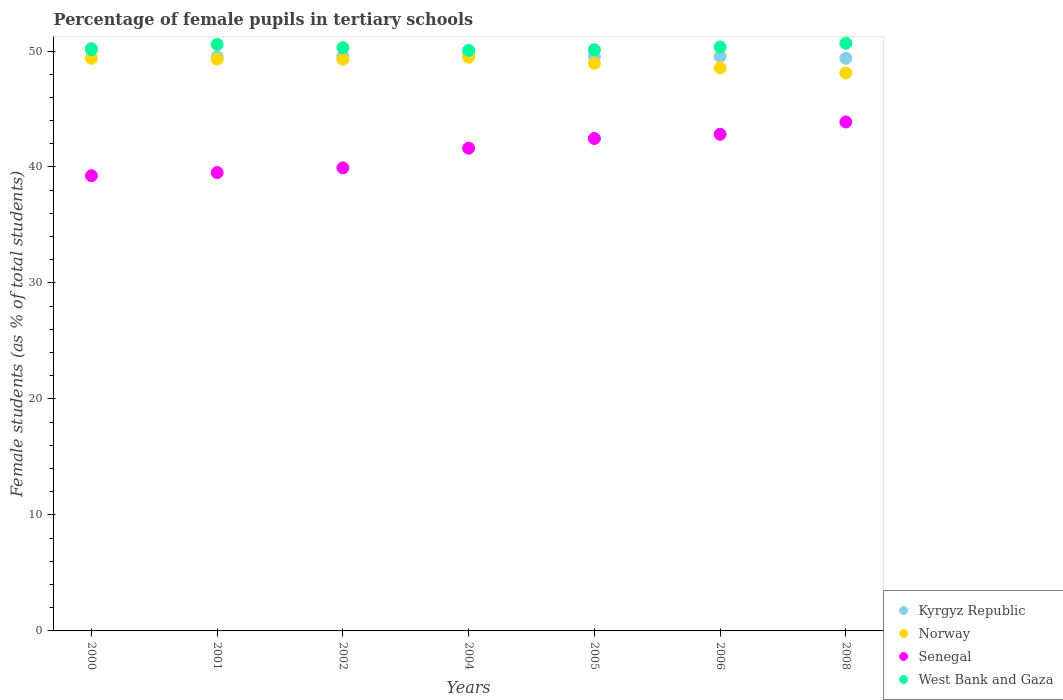How many different coloured dotlines are there?
Your response must be concise. 4. What is the percentage of female pupils in tertiary schools in Kyrgyz Republic in 2008?
Make the answer very short. 49.37. Across all years, what is the maximum percentage of female pupils in tertiary schools in Kyrgyz Republic?
Provide a succinct answer. 50.24. Across all years, what is the minimum percentage of female pupils in tertiary schools in Kyrgyz Republic?
Offer a terse response. 49.37. In which year was the percentage of female pupils in tertiary schools in West Bank and Gaza maximum?
Make the answer very short. 2008. In which year was the percentage of female pupils in tertiary schools in Norway minimum?
Offer a very short reply. 2008. What is the total percentage of female pupils in tertiary schools in Norway in the graph?
Your response must be concise. 342.99. What is the difference between the percentage of female pupils in tertiary schools in Kyrgyz Republic in 2001 and that in 2004?
Your answer should be compact. -0.11. What is the difference between the percentage of female pupils in tertiary schools in Norway in 2006 and the percentage of female pupils in tertiary schools in Kyrgyz Republic in 2008?
Provide a short and direct response. -0.84. What is the average percentage of female pupils in tertiary schools in West Bank and Gaza per year?
Offer a very short reply. 50.31. In the year 2008, what is the difference between the percentage of female pupils in tertiary schools in Norway and percentage of female pupils in tertiary schools in West Bank and Gaza?
Offer a terse response. -2.57. What is the ratio of the percentage of female pupils in tertiary schools in Norway in 2000 to that in 2005?
Your response must be concise. 1.01. Is the percentage of female pupils in tertiary schools in West Bank and Gaza in 2000 less than that in 2005?
Offer a very short reply. No. What is the difference between the highest and the second highest percentage of female pupils in tertiary schools in West Bank and Gaza?
Offer a very short reply. 0.1. What is the difference between the highest and the lowest percentage of female pupils in tertiary schools in West Bank and Gaza?
Your answer should be compact. 0.62. Is the percentage of female pupils in tertiary schools in Senegal strictly greater than the percentage of female pupils in tertiary schools in Kyrgyz Republic over the years?
Keep it short and to the point. No. Is the percentage of female pupils in tertiary schools in West Bank and Gaza strictly less than the percentage of female pupils in tertiary schools in Kyrgyz Republic over the years?
Your response must be concise. No. How many dotlines are there?
Provide a succinct answer. 4. Does the graph contain grids?
Offer a terse response. No. Where does the legend appear in the graph?
Make the answer very short. Bottom right. How many legend labels are there?
Offer a terse response. 4. What is the title of the graph?
Provide a short and direct response. Percentage of female pupils in tertiary schools. What is the label or title of the X-axis?
Provide a short and direct response. Years. What is the label or title of the Y-axis?
Make the answer very short. Female students (as % of total students). What is the Female students (as % of total students) of Kyrgyz Republic in 2000?
Give a very brief answer. 50.24. What is the Female students (as % of total students) of Norway in 2000?
Your answer should be very brief. 49.37. What is the Female students (as % of total students) in Senegal in 2000?
Offer a terse response. 39.25. What is the Female students (as % of total students) in West Bank and Gaza in 2000?
Provide a short and direct response. 50.12. What is the Female students (as % of total students) of Kyrgyz Republic in 2001?
Provide a short and direct response. 49.5. What is the Female students (as % of total students) in Norway in 2001?
Ensure brevity in your answer.  49.3. What is the Female students (as % of total students) of Senegal in 2001?
Make the answer very short. 39.52. What is the Female students (as % of total students) in West Bank and Gaza in 2001?
Your answer should be very brief. 50.57. What is the Female students (as % of total students) of Kyrgyz Republic in 2002?
Keep it short and to the point. 49.55. What is the Female students (as % of total students) of Norway in 2002?
Your answer should be very brief. 49.29. What is the Female students (as % of total students) in Senegal in 2002?
Your answer should be compact. 39.92. What is the Female students (as % of total students) in West Bank and Gaza in 2002?
Make the answer very short. 50.29. What is the Female students (as % of total students) in Kyrgyz Republic in 2004?
Provide a succinct answer. 49.61. What is the Female students (as % of total students) in Norway in 2004?
Give a very brief answer. 49.46. What is the Female students (as % of total students) of Senegal in 2004?
Your response must be concise. 41.62. What is the Female students (as % of total students) of West Bank and Gaza in 2004?
Your answer should be compact. 50.05. What is the Female students (as % of total students) in Kyrgyz Republic in 2005?
Give a very brief answer. 49.5. What is the Female students (as % of total students) of Norway in 2005?
Your answer should be compact. 48.94. What is the Female students (as % of total students) of Senegal in 2005?
Offer a terse response. 42.46. What is the Female students (as % of total students) in West Bank and Gaza in 2005?
Offer a terse response. 50.11. What is the Female students (as % of total students) in Kyrgyz Republic in 2006?
Your response must be concise. 49.53. What is the Female students (as % of total students) of Norway in 2006?
Offer a very short reply. 48.54. What is the Female students (as % of total students) in Senegal in 2006?
Your answer should be very brief. 42.82. What is the Female students (as % of total students) of West Bank and Gaza in 2006?
Provide a short and direct response. 50.35. What is the Female students (as % of total students) in Kyrgyz Republic in 2008?
Your response must be concise. 49.37. What is the Female students (as % of total students) of Norway in 2008?
Your answer should be compact. 48.1. What is the Female students (as % of total students) of Senegal in 2008?
Ensure brevity in your answer.  43.88. What is the Female students (as % of total students) of West Bank and Gaza in 2008?
Give a very brief answer. 50.67. Across all years, what is the maximum Female students (as % of total students) of Kyrgyz Republic?
Your response must be concise. 50.24. Across all years, what is the maximum Female students (as % of total students) of Norway?
Keep it short and to the point. 49.46. Across all years, what is the maximum Female students (as % of total students) of Senegal?
Make the answer very short. 43.88. Across all years, what is the maximum Female students (as % of total students) in West Bank and Gaza?
Your answer should be very brief. 50.67. Across all years, what is the minimum Female students (as % of total students) in Kyrgyz Republic?
Give a very brief answer. 49.37. Across all years, what is the minimum Female students (as % of total students) in Norway?
Offer a terse response. 48.1. Across all years, what is the minimum Female students (as % of total students) of Senegal?
Keep it short and to the point. 39.25. Across all years, what is the minimum Female students (as % of total students) of West Bank and Gaza?
Keep it short and to the point. 50.05. What is the total Female students (as % of total students) in Kyrgyz Republic in the graph?
Your response must be concise. 347.3. What is the total Female students (as % of total students) in Norway in the graph?
Your answer should be very brief. 342.99. What is the total Female students (as % of total students) of Senegal in the graph?
Give a very brief answer. 289.47. What is the total Female students (as % of total students) of West Bank and Gaza in the graph?
Provide a succinct answer. 352.15. What is the difference between the Female students (as % of total students) of Kyrgyz Republic in 2000 and that in 2001?
Offer a very short reply. 0.74. What is the difference between the Female students (as % of total students) of Norway in 2000 and that in 2001?
Give a very brief answer. 0.08. What is the difference between the Female students (as % of total students) in Senegal in 2000 and that in 2001?
Your answer should be compact. -0.27. What is the difference between the Female students (as % of total students) of West Bank and Gaza in 2000 and that in 2001?
Make the answer very short. -0.46. What is the difference between the Female students (as % of total students) of Kyrgyz Republic in 2000 and that in 2002?
Your answer should be compact. 0.69. What is the difference between the Female students (as % of total students) in Norway in 2000 and that in 2002?
Offer a terse response. 0.08. What is the difference between the Female students (as % of total students) in Senegal in 2000 and that in 2002?
Keep it short and to the point. -0.68. What is the difference between the Female students (as % of total students) in West Bank and Gaza in 2000 and that in 2002?
Offer a terse response. -0.17. What is the difference between the Female students (as % of total students) of Kyrgyz Republic in 2000 and that in 2004?
Provide a short and direct response. 0.63. What is the difference between the Female students (as % of total students) of Norway in 2000 and that in 2004?
Your answer should be compact. -0.09. What is the difference between the Female students (as % of total students) of Senegal in 2000 and that in 2004?
Your response must be concise. -2.38. What is the difference between the Female students (as % of total students) in West Bank and Gaza in 2000 and that in 2004?
Offer a terse response. 0.07. What is the difference between the Female students (as % of total students) of Kyrgyz Republic in 2000 and that in 2005?
Ensure brevity in your answer.  0.74. What is the difference between the Female students (as % of total students) of Norway in 2000 and that in 2005?
Provide a succinct answer. 0.43. What is the difference between the Female students (as % of total students) in Senegal in 2000 and that in 2005?
Your response must be concise. -3.21. What is the difference between the Female students (as % of total students) of West Bank and Gaza in 2000 and that in 2005?
Provide a succinct answer. 0.01. What is the difference between the Female students (as % of total students) in Norway in 2000 and that in 2006?
Your answer should be compact. 0.84. What is the difference between the Female students (as % of total students) of Senegal in 2000 and that in 2006?
Your answer should be very brief. -3.57. What is the difference between the Female students (as % of total students) of West Bank and Gaza in 2000 and that in 2006?
Your answer should be very brief. -0.23. What is the difference between the Female students (as % of total students) in Kyrgyz Republic in 2000 and that in 2008?
Give a very brief answer. 0.87. What is the difference between the Female students (as % of total students) in Norway in 2000 and that in 2008?
Your answer should be compact. 1.27. What is the difference between the Female students (as % of total students) in Senegal in 2000 and that in 2008?
Your answer should be very brief. -4.64. What is the difference between the Female students (as % of total students) in West Bank and Gaza in 2000 and that in 2008?
Give a very brief answer. -0.56. What is the difference between the Female students (as % of total students) in Kyrgyz Republic in 2001 and that in 2002?
Provide a short and direct response. -0.05. What is the difference between the Female students (as % of total students) of Norway in 2001 and that in 2002?
Your response must be concise. 0.01. What is the difference between the Female students (as % of total students) in Senegal in 2001 and that in 2002?
Your answer should be very brief. -0.41. What is the difference between the Female students (as % of total students) in West Bank and Gaza in 2001 and that in 2002?
Your answer should be compact. 0.29. What is the difference between the Female students (as % of total students) in Kyrgyz Republic in 2001 and that in 2004?
Your answer should be compact. -0.11. What is the difference between the Female students (as % of total students) in Norway in 2001 and that in 2004?
Offer a terse response. -0.17. What is the difference between the Female students (as % of total students) in Senegal in 2001 and that in 2004?
Ensure brevity in your answer.  -2.1. What is the difference between the Female students (as % of total students) of West Bank and Gaza in 2001 and that in 2004?
Your answer should be compact. 0.52. What is the difference between the Female students (as % of total students) of Kyrgyz Republic in 2001 and that in 2005?
Keep it short and to the point. 0. What is the difference between the Female students (as % of total students) of Norway in 2001 and that in 2005?
Offer a terse response. 0.36. What is the difference between the Female students (as % of total students) of Senegal in 2001 and that in 2005?
Keep it short and to the point. -2.94. What is the difference between the Female students (as % of total students) in West Bank and Gaza in 2001 and that in 2005?
Offer a very short reply. 0.46. What is the difference between the Female students (as % of total students) of Kyrgyz Republic in 2001 and that in 2006?
Offer a terse response. -0.02. What is the difference between the Female students (as % of total students) in Norway in 2001 and that in 2006?
Make the answer very short. 0.76. What is the difference between the Female students (as % of total students) of Senegal in 2001 and that in 2006?
Provide a short and direct response. -3.3. What is the difference between the Female students (as % of total students) in West Bank and Gaza in 2001 and that in 2006?
Your answer should be very brief. 0.22. What is the difference between the Female students (as % of total students) in Kyrgyz Republic in 2001 and that in 2008?
Offer a terse response. 0.13. What is the difference between the Female students (as % of total students) in Norway in 2001 and that in 2008?
Keep it short and to the point. 1.2. What is the difference between the Female students (as % of total students) of Senegal in 2001 and that in 2008?
Keep it short and to the point. -4.36. What is the difference between the Female students (as % of total students) of West Bank and Gaza in 2001 and that in 2008?
Ensure brevity in your answer.  -0.1. What is the difference between the Female students (as % of total students) in Kyrgyz Republic in 2002 and that in 2004?
Offer a very short reply. -0.06. What is the difference between the Female students (as % of total students) in Norway in 2002 and that in 2004?
Offer a terse response. -0.17. What is the difference between the Female students (as % of total students) of Senegal in 2002 and that in 2004?
Offer a very short reply. -1.7. What is the difference between the Female students (as % of total students) of West Bank and Gaza in 2002 and that in 2004?
Your answer should be compact. 0.24. What is the difference between the Female students (as % of total students) of Kyrgyz Republic in 2002 and that in 2005?
Provide a short and direct response. 0.06. What is the difference between the Female students (as % of total students) in Norway in 2002 and that in 2005?
Your response must be concise. 0.35. What is the difference between the Female students (as % of total students) in Senegal in 2002 and that in 2005?
Make the answer very short. -2.53. What is the difference between the Female students (as % of total students) of West Bank and Gaza in 2002 and that in 2005?
Offer a very short reply. 0.18. What is the difference between the Female students (as % of total students) in Kyrgyz Republic in 2002 and that in 2006?
Your answer should be very brief. 0.03. What is the difference between the Female students (as % of total students) in Norway in 2002 and that in 2006?
Offer a very short reply. 0.75. What is the difference between the Female students (as % of total students) of Senegal in 2002 and that in 2006?
Provide a short and direct response. -2.89. What is the difference between the Female students (as % of total students) of West Bank and Gaza in 2002 and that in 2006?
Offer a very short reply. -0.06. What is the difference between the Female students (as % of total students) in Kyrgyz Republic in 2002 and that in 2008?
Keep it short and to the point. 0.18. What is the difference between the Female students (as % of total students) of Norway in 2002 and that in 2008?
Offer a very short reply. 1.19. What is the difference between the Female students (as % of total students) of Senegal in 2002 and that in 2008?
Your response must be concise. -3.96. What is the difference between the Female students (as % of total students) of West Bank and Gaza in 2002 and that in 2008?
Your response must be concise. -0.39. What is the difference between the Female students (as % of total students) of Kyrgyz Republic in 2004 and that in 2005?
Keep it short and to the point. 0.11. What is the difference between the Female students (as % of total students) in Norway in 2004 and that in 2005?
Provide a succinct answer. 0.52. What is the difference between the Female students (as % of total students) in Senegal in 2004 and that in 2005?
Offer a terse response. -0.84. What is the difference between the Female students (as % of total students) in West Bank and Gaza in 2004 and that in 2005?
Your response must be concise. -0.06. What is the difference between the Female students (as % of total students) in Kyrgyz Republic in 2004 and that in 2006?
Your answer should be compact. 0.08. What is the difference between the Female students (as % of total students) of Norway in 2004 and that in 2006?
Give a very brief answer. 0.93. What is the difference between the Female students (as % of total students) of Senegal in 2004 and that in 2006?
Offer a terse response. -1.2. What is the difference between the Female students (as % of total students) in West Bank and Gaza in 2004 and that in 2006?
Provide a short and direct response. -0.3. What is the difference between the Female students (as % of total students) of Kyrgyz Republic in 2004 and that in 2008?
Offer a terse response. 0.24. What is the difference between the Female students (as % of total students) in Norway in 2004 and that in 2008?
Your response must be concise. 1.36. What is the difference between the Female students (as % of total students) in Senegal in 2004 and that in 2008?
Give a very brief answer. -2.26. What is the difference between the Female students (as % of total students) of West Bank and Gaza in 2004 and that in 2008?
Provide a succinct answer. -0.62. What is the difference between the Female students (as % of total students) in Kyrgyz Republic in 2005 and that in 2006?
Your answer should be compact. -0.03. What is the difference between the Female students (as % of total students) of Norway in 2005 and that in 2006?
Your answer should be very brief. 0.4. What is the difference between the Female students (as % of total students) of Senegal in 2005 and that in 2006?
Offer a very short reply. -0.36. What is the difference between the Female students (as % of total students) in West Bank and Gaza in 2005 and that in 2006?
Your answer should be very brief. -0.24. What is the difference between the Female students (as % of total students) of Kyrgyz Republic in 2005 and that in 2008?
Provide a succinct answer. 0.13. What is the difference between the Female students (as % of total students) of Norway in 2005 and that in 2008?
Provide a short and direct response. 0.84. What is the difference between the Female students (as % of total students) of Senegal in 2005 and that in 2008?
Provide a succinct answer. -1.43. What is the difference between the Female students (as % of total students) in West Bank and Gaza in 2005 and that in 2008?
Your answer should be compact. -0.57. What is the difference between the Female students (as % of total students) in Kyrgyz Republic in 2006 and that in 2008?
Offer a very short reply. 0.15. What is the difference between the Female students (as % of total students) in Norway in 2006 and that in 2008?
Give a very brief answer. 0.43. What is the difference between the Female students (as % of total students) in Senegal in 2006 and that in 2008?
Give a very brief answer. -1.06. What is the difference between the Female students (as % of total students) of West Bank and Gaza in 2006 and that in 2008?
Ensure brevity in your answer.  -0.32. What is the difference between the Female students (as % of total students) in Kyrgyz Republic in 2000 and the Female students (as % of total students) in Norway in 2001?
Your answer should be compact. 0.94. What is the difference between the Female students (as % of total students) of Kyrgyz Republic in 2000 and the Female students (as % of total students) of Senegal in 2001?
Your answer should be very brief. 10.72. What is the difference between the Female students (as % of total students) of Kyrgyz Republic in 2000 and the Female students (as % of total students) of West Bank and Gaza in 2001?
Ensure brevity in your answer.  -0.33. What is the difference between the Female students (as % of total students) in Norway in 2000 and the Female students (as % of total students) in Senegal in 2001?
Offer a terse response. 9.85. What is the difference between the Female students (as % of total students) in Norway in 2000 and the Female students (as % of total students) in West Bank and Gaza in 2001?
Provide a succinct answer. -1.2. What is the difference between the Female students (as % of total students) in Senegal in 2000 and the Female students (as % of total students) in West Bank and Gaza in 2001?
Provide a succinct answer. -11.33. What is the difference between the Female students (as % of total students) in Kyrgyz Republic in 2000 and the Female students (as % of total students) in Norway in 2002?
Provide a short and direct response. 0.95. What is the difference between the Female students (as % of total students) of Kyrgyz Republic in 2000 and the Female students (as % of total students) of Senegal in 2002?
Offer a very short reply. 10.32. What is the difference between the Female students (as % of total students) of Kyrgyz Republic in 2000 and the Female students (as % of total students) of West Bank and Gaza in 2002?
Offer a very short reply. -0.05. What is the difference between the Female students (as % of total students) of Norway in 2000 and the Female students (as % of total students) of Senegal in 2002?
Offer a very short reply. 9.45. What is the difference between the Female students (as % of total students) in Norway in 2000 and the Female students (as % of total students) in West Bank and Gaza in 2002?
Keep it short and to the point. -0.92. What is the difference between the Female students (as % of total students) in Senegal in 2000 and the Female students (as % of total students) in West Bank and Gaza in 2002?
Your response must be concise. -11.04. What is the difference between the Female students (as % of total students) in Kyrgyz Republic in 2000 and the Female students (as % of total students) in Norway in 2004?
Provide a short and direct response. 0.78. What is the difference between the Female students (as % of total students) of Kyrgyz Republic in 2000 and the Female students (as % of total students) of Senegal in 2004?
Your answer should be compact. 8.62. What is the difference between the Female students (as % of total students) in Kyrgyz Republic in 2000 and the Female students (as % of total students) in West Bank and Gaza in 2004?
Provide a short and direct response. 0.19. What is the difference between the Female students (as % of total students) in Norway in 2000 and the Female students (as % of total students) in Senegal in 2004?
Keep it short and to the point. 7.75. What is the difference between the Female students (as % of total students) in Norway in 2000 and the Female students (as % of total students) in West Bank and Gaza in 2004?
Ensure brevity in your answer.  -0.68. What is the difference between the Female students (as % of total students) of Senegal in 2000 and the Female students (as % of total students) of West Bank and Gaza in 2004?
Ensure brevity in your answer.  -10.81. What is the difference between the Female students (as % of total students) of Kyrgyz Republic in 2000 and the Female students (as % of total students) of Norway in 2005?
Keep it short and to the point. 1.3. What is the difference between the Female students (as % of total students) in Kyrgyz Republic in 2000 and the Female students (as % of total students) in Senegal in 2005?
Provide a succinct answer. 7.78. What is the difference between the Female students (as % of total students) in Kyrgyz Republic in 2000 and the Female students (as % of total students) in West Bank and Gaza in 2005?
Provide a succinct answer. 0.13. What is the difference between the Female students (as % of total students) of Norway in 2000 and the Female students (as % of total students) of Senegal in 2005?
Ensure brevity in your answer.  6.91. What is the difference between the Female students (as % of total students) of Norway in 2000 and the Female students (as % of total students) of West Bank and Gaza in 2005?
Make the answer very short. -0.74. What is the difference between the Female students (as % of total students) in Senegal in 2000 and the Female students (as % of total students) in West Bank and Gaza in 2005?
Offer a terse response. -10.86. What is the difference between the Female students (as % of total students) in Kyrgyz Republic in 2000 and the Female students (as % of total students) in Norway in 2006?
Offer a terse response. 1.7. What is the difference between the Female students (as % of total students) in Kyrgyz Republic in 2000 and the Female students (as % of total students) in Senegal in 2006?
Give a very brief answer. 7.42. What is the difference between the Female students (as % of total students) in Kyrgyz Republic in 2000 and the Female students (as % of total students) in West Bank and Gaza in 2006?
Your answer should be compact. -0.11. What is the difference between the Female students (as % of total students) in Norway in 2000 and the Female students (as % of total students) in Senegal in 2006?
Provide a succinct answer. 6.55. What is the difference between the Female students (as % of total students) in Norway in 2000 and the Female students (as % of total students) in West Bank and Gaza in 2006?
Give a very brief answer. -0.98. What is the difference between the Female students (as % of total students) in Senegal in 2000 and the Female students (as % of total students) in West Bank and Gaza in 2006?
Your response must be concise. -11.1. What is the difference between the Female students (as % of total students) in Kyrgyz Republic in 2000 and the Female students (as % of total students) in Norway in 2008?
Offer a very short reply. 2.14. What is the difference between the Female students (as % of total students) in Kyrgyz Republic in 2000 and the Female students (as % of total students) in Senegal in 2008?
Provide a short and direct response. 6.36. What is the difference between the Female students (as % of total students) in Kyrgyz Republic in 2000 and the Female students (as % of total students) in West Bank and Gaza in 2008?
Give a very brief answer. -0.43. What is the difference between the Female students (as % of total students) in Norway in 2000 and the Female students (as % of total students) in Senegal in 2008?
Your response must be concise. 5.49. What is the difference between the Female students (as % of total students) of Norway in 2000 and the Female students (as % of total students) of West Bank and Gaza in 2008?
Provide a short and direct response. -1.3. What is the difference between the Female students (as % of total students) of Senegal in 2000 and the Female students (as % of total students) of West Bank and Gaza in 2008?
Provide a succinct answer. -11.43. What is the difference between the Female students (as % of total students) in Kyrgyz Republic in 2001 and the Female students (as % of total students) in Norway in 2002?
Offer a terse response. 0.21. What is the difference between the Female students (as % of total students) of Kyrgyz Republic in 2001 and the Female students (as % of total students) of Senegal in 2002?
Provide a short and direct response. 9.58. What is the difference between the Female students (as % of total students) in Kyrgyz Republic in 2001 and the Female students (as % of total students) in West Bank and Gaza in 2002?
Offer a very short reply. -0.79. What is the difference between the Female students (as % of total students) of Norway in 2001 and the Female students (as % of total students) of Senegal in 2002?
Offer a terse response. 9.37. What is the difference between the Female students (as % of total students) in Norway in 2001 and the Female students (as % of total students) in West Bank and Gaza in 2002?
Your answer should be very brief. -0.99. What is the difference between the Female students (as % of total students) in Senegal in 2001 and the Female students (as % of total students) in West Bank and Gaza in 2002?
Offer a very short reply. -10.77. What is the difference between the Female students (as % of total students) of Kyrgyz Republic in 2001 and the Female students (as % of total students) of Norway in 2004?
Your response must be concise. 0.04. What is the difference between the Female students (as % of total students) of Kyrgyz Republic in 2001 and the Female students (as % of total students) of Senegal in 2004?
Your response must be concise. 7.88. What is the difference between the Female students (as % of total students) in Kyrgyz Republic in 2001 and the Female students (as % of total students) in West Bank and Gaza in 2004?
Make the answer very short. -0.55. What is the difference between the Female students (as % of total students) in Norway in 2001 and the Female students (as % of total students) in Senegal in 2004?
Ensure brevity in your answer.  7.67. What is the difference between the Female students (as % of total students) of Norway in 2001 and the Female students (as % of total students) of West Bank and Gaza in 2004?
Offer a very short reply. -0.76. What is the difference between the Female students (as % of total students) in Senegal in 2001 and the Female students (as % of total students) in West Bank and Gaza in 2004?
Offer a very short reply. -10.53. What is the difference between the Female students (as % of total students) of Kyrgyz Republic in 2001 and the Female students (as % of total students) of Norway in 2005?
Make the answer very short. 0.56. What is the difference between the Female students (as % of total students) of Kyrgyz Republic in 2001 and the Female students (as % of total students) of Senegal in 2005?
Keep it short and to the point. 7.04. What is the difference between the Female students (as % of total students) in Kyrgyz Republic in 2001 and the Female students (as % of total students) in West Bank and Gaza in 2005?
Keep it short and to the point. -0.61. What is the difference between the Female students (as % of total students) in Norway in 2001 and the Female students (as % of total students) in Senegal in 2005?
Offer a terse response. 6.84. What is the difference between the Female students (as % of total students) of Norway in 2001 and the Female students (as % of total students) of West Bank and Gaza in 2005?
Offer a terse response. -0.81. What is the difference between the Female students (as % of total students) of Senegal in 2001 and the Female students (as % of total students) of West Bank and Gaza in 2005?
Your answer should be compact. -10.59. What is the difference between the Female students (as % of total students) in Kyrgyz Republic in 2001 and the Female students (as % of total students) in Norway in 2006?
Offer a very short reply. 0.97. What is the difference between the Female students (as % of total students) in Kyrgyz Republic in 2001 and the Female students (as % of total students) in Senegal in 2006?
Your answer should be very brief. 6.68. What is the difference between the Female students (as % of total students) of Kyrgyz Republic in 2001 and the Female students (as % of total students) of West Bank and Gaza in 2006?
Provide a short and direct response. -0.85. What is the difference between the Female students (as % of total students) in Norway in 2001 and the Female students (as % of total students) in Senegal in 2006?
Give a very brief answer. 6.48. What is the difference between the Female students (as % of total students) of Norway in 2001 and the Female students (as % of total students) of West Bank and Gaza in 2006?
Provide a short and direct response. -1.05. What is the difference between the Female students (as % of total students) of Senegal in 2001 and the Female students (as % of total students) of West Bank and Gaza in 2006?
Your answer should be very brief. -10.83. What is the difference between the Female students (as % of total students) of Kyrgyz Republic in 2001 and the Female students (as % of total students) of Norway in 2008?
Your answer should be very brief. 1.4. What is the difference between the Female students (as % of total students) in Kyrgyz Republic in 2001 and the Female students (as % of total students) in Senegal in 2008?
Make the answer very short. 5.62. What is the difference between the Female students (as % of total students) of Kyrgyz Republic in 2001 and the Female students (as % of total students) of West Bank and Gaza in 2008?
Provide a succinct answer. -1.17. What is the difference between the Female students (as % of total students) in Norway in 2001 and the Female students (as % of total students) in Senegal in 2008?
Your response must be concise. 5.41. What is the difference between the Female students (as % of total students) in Norway in 2001 and the Female students (as % of total students) in West Bank and Gaza in 2008?
Your answer should be very brief. -1.38. What is the difference between the Female students (as % of total students) of Senegal in 2001 and the Female students (as % of total students) of West Bank and Gaza in 2008?
Provide a short and direct response. -11.15. What is the difference between the Female students (as % of total students) in Kyrgyz Republic in 2002 and the Female students (as % of total students) in Norway in 2004?
Keep it short and to the point. 0.09. What is the difference between the Female students (as % of total students) of Kyrgyz Republic in 2002 and the Female students (as % of total students) of Senegal in 2004?
Offer a very short reply. 7.93. What is the difference between the Female students (as % of total students) of Kyrgyz Republic in 2002 and the Female students (as % of total students) of West Bank and Gaza in 2004?
Make the answer very short. -0.5. What is the difference between the Female students (as % of total students) in Norway in 2002 and the Female students (as % of total students) in Senegal in 2004?
Your answer should be very brief. 7.67. What is the difference between the Female students (as % of total students) in Norway in 2002 and the Female students (as % of total students) in West Bank and Gaza in 2004?
Provide a short and direct response. -0.76. What is the difference between the Female students (as % of total students) in Senegal in 2002 and the Female students (as % of total students) in West Bank and Gaza in 2004?
Provide a short and direct response. -10.13. What is the difference between the Female students (as % of total students) in Kyrgyz Republic in 2002 and the Female students (as % of total students) in Norway in 2005?
Provide a short and direct response. 0.61. What is the difference between the Female students (as % of total students) in Kyrgyz Republic in 2002 and the Female students (as % of total students) in Senegal in 2005?
Ensure brevity in your answer.  7.1. What is the difference between the Female students (as % of total students) in Kyrgyz Republic in 2002 and the Female students (as % of total students) in West Bank and Gaza in 2005?
Your answer should be compact. -0.55. What is the difference between the Female students (as % of total students) in Norway in 2002 and the Female students (as % of total students) in Senegal in 2005?
Your answer should be compact. 6.83. What is the difference between the Female students (as % of total students) in Norway in 2002 and the Female students (as % of total students) in West Bank and Gaza in 2005?
Provide a short and direct response. -0.82. What is the difference between the Female students (as % of total students) of Senegal in 2002 and the Female students (as % of total students) of West Bank and Gaza in 2005?
Give a very brief answer. -10.18. What is the difference between the Female students (as % of total students) in Kyrgyz Republic in 2002 and the Female students (as % of total students) in Norway in 2006?
Keep it short and to the point. 1.02. What is the difference between the Female students (as % of total students) of Kyrgyz Republic in 2002 and the Female students (as % of total students) of Senegal in 2006?
Provide a succinct answer. 6.74. What is the difference between the Female students (as % of total students) in Kyrgyz Republic in 2002 and the Female students (as % of total students) in West Bank and Gaza in 2006?
Your answer should be very brief. -0.79. What is the difference between the Female students (as % of total students) of Norway in 2002 and the Female students (as % of total students) of Senegal in 2006?
Keep it short and to the point. 6.47. What is the difference between the Female students (as % of total students) of Norway in 2002 and the Female students (as % of total students) of West Bank and Gaza in 2006?
Your answer should be compact. -1.06. What is the difference between the Female students (as % of total students) of Senegal in 2002 and the Female students (as % of total students) of West Bank and Gaza in 2006?
Make the answer very short. -10.42. What is the difference between the Female students (as % of total students) of Kyrgyz Republic in 2002 and the Female students (as % of total students) of Norway in 2008?
Your answer should be compact. 1.45. What is the difference between the Female students (as % of total students) in Kyrgyz Republic in 2002 and the Female students (as % of total students) in Senegal in 2008?
Keep it short and to the point. 5.67. What is the difference between the Female students (as % of total students) of Kyrgyz Republic in 2002 and the Female students (as % of total students) of West Bank and Gaza in 2008?
Provide a succinct answer. -1.12. What is the difference between the Female students (as % of total students) in Norway in 2002 and the Female students (as % of total students) in Senegal in 2008?
Offer a very short reply. 5.41. What is the difference between the Female students (as % of total students) in Norway in 2002 and the Female students (as % of total students) in West Bank and Gaza in 2008?
Ensure brevity in your answer.  -1.38. What is the difference between the Female students (as % of total students) of Senegal in 2002 and the Female students (as % of total students) of West Bank and Gaza in 2008?
Your answer should be compact. -10.75. What is the difference between the Female students (as % of total students) of Kyrgyz Republic in 2004 and the Female students (as % of total students) of Norway in 2005?
Ensure brevity in your answer.  0.67. What is the difference between the Female students (as % of total students) in Kyrgyz Republic in 2004 and the Female students (as % of total students) in Senegal in 2005?
Your answer should be very brief. 7.15. What is the difference between the Female students (as % of total students) of Kyrgyz Republic in 2004 and the Female students (as % of total students) of West Bank and Gaza in 2005?
Make the answer very short. -0.5. What is the difference between the Female students (as % of total students) of Norway in 2004 and the Female students (as % of total students) of Senegal in 2005?
Your response must be concise. 7.01. What is the difference between the Female students (as % of total students) of Norway in 2004 and the Female students (as % of total students) of West Bank and Gaza in 2005?
Your answer should be compact. -0.64. What is the difference between the Female students (as % of total students) of Senegal in 2004 and the Female students (as % of total students) of West Bank and Gaza in 2005?
Offer a terse response. -8.49. What is the difference between the Female students (as % of total students) of Kyrgyz Republic in 2004 and the Female students (as % of total students) of Norway in 2006?
Provide a succinct answer. 1.07. What is the difference between the Female students (as % of total students) in Kyrgyz Republic in 2004 and the Female students (as % of total students) in Senegal in 2006?
Provide a succinct answer. 6.79. What is the difference between the Female students (as % of total students) in Kyrgyz Republic in 2004 and the Female students (as % of total students) in West Bank and Gaza in 2006?
Provide a short and direct response. -0.74. What is the difference between the Female students (as % of total students) of Norway in 2004 and the Female students (as % of total students) of Senegal in 2006?
Offer a terse response. 6.64. What is the difference between the Female students (as % of total students) in Norway in 2004 and the Female students (as % of total students) in West Bank and Gaza in 2006?
Make the answer very short. -0.89. What is the difference between the Female students (as % of total students) of Senegal in 2004 and the Female students (as % of total students) of West Bank and Gaza in 2006?
Make the answer very short. -8.73. What is the difference between the Female students (as % of total students) in Kyrgyz Republic in 2004 and the Female students (as % of total students) in Norway in 2008?
Ensure brevity in your answer.  1.51. What is the difference between the Female students (as % of total students) in Kyrgyz Republic in 2004 and the Female students (as % of total students) in Senegal in 2008?
Offer a very short reply. 5.73. What is the difference between the Female students (as % of total students) of Kyrgyz Republic in 2004 and the Female students (as % of total students) of West Bank and Gaza in 2008?
Your response must be concise. -1.06. What is the difference between the Female students (as % of total students) of Norway in 2004 and the Female students (as % of total students) of Senegal in 2008?
Offer a very short reply. 5.58. What is the difference between the Female students (as % of total students) in Norway in 2004 and the Female students (as % of total students) in West Bank and Gaza in 2008?
Provide a short and direct response. -1.21. What is the difference between the Female students (as % of total students) in Senegal in 2004 and the Female students (as % of total students) in West Bank and Gaza in 2008?
Make the answer very short. -9.05. What is the difference between the Female students (as % of total students) in Kyrgyz Republic in 2005 and the Female students (as % of total students) in Norway in 2006?
Make the answer very short. 0.96. What is the difference between the Female students (as % of total students) in Kyrgyz Republic in 2005 and the Female students (as % of total students) in Senegal in 2006?
Provide a short and direct response. 6.68. What is the difference between the Female students (as % of total students) of Kyrgyz Republic in 2005 and the Female students (as % of total students) of West Bank and Gaza in 2006?
Your answer should be compact. -0.85. What is the difference between the Female students (as % of total students) of Norway in 2005 and the Female students (as % of total students) of Senegal in 2006?
Your answer should be very brief. 6.12. What is the difference between the Female students (as % of total students) in Norway in 2005 and the Female students (as % of total students) in West Bank and Gaza in 2006?
Ensure brevity in your answer.  -1.41. What is the difference between the Female students (as % of total students) of Senegal in 2005 and the Female students (as % of total students) of West Bank and Gaza in 2006?
Give a very brief answer. -7.89. What is the difference between the Female students (as % of total students) of Kyrgyz Republic in 2005 and the Female students (as % of total students) of Norway in 2008?
Give a very brief answer. 1.4. What is the difference between the Female students (as % of total students) in Kyrgyz Republic in 2005 and the Female students (as % of total students) in Senegal in 2008?
Keep it short and to the point. 5.62. What is the difference between the Female students (as % of total students) of Kyrgyz Republic in 2005 and the Female students (as % of total students) of West Bank and Gaza in 2008?
Provide a succinct answer. -1.17. What is the difference between the Female students (as % of total students) of Norway in 2005 and the Female students (as % of total students) of Senegal in 2008?
Your response must be concise. 5.06. What is the difference between the Female students (as % of total students) in Norway in 2005 and the Female students (as % of total students) in West Bank and Gaza in 2008?
Your response must be concise. -1.73. What is the difference between the Female students (as % of total students) in Senegal in 2005 and the Female students (as % of total students) in West Bank and Gaza in 2008?
Keep it short and to the point. -8.22. What is the difference between the Female students (as % of total students) in Kyrgyz Republic in 2006 and the Female students (as % of total students) in Norway in 2008?
Your answer should be very brief. 1.43. What is the difference between the Female students (as % of total students) in Kyrgyz Republic in 2006 and the Female students (as % of total students) in Senegal in 2008?
Ensure brevity in your answer.  5.64. What is the difference between the Female students (as % of total students) of Kyrgyz Republic in 2006 and the Female students (as % of total students) of West Bank and Gaza in 2008?
Your answer should be compact. -1.15. What is the difference between the Female students (as % of total students) of Norway in 2006 and the Female students (as % of total students) of Senegal in 2008?
Provide a short and direct response. 4.65. What is the difference between the Female students (as % of total students) in Norway in 2006 and the Female students (as % of total students) in West Bank and Gaza in 2008?
Give a very brief answer. -2.14. What is the difference between the Female students (as % of total students) in Senegal in 2006 and the Female students (as % of total students) in West Bank and Gaza in 2008?
Make the answer very short. -7.85. What is the average Female students (as % of total students) of Kyrgyz Republic per year?
Provide a succinct answer. 49.61. What is the average Female students (as % of total students) of Norway per year?
Your answer should be very brief. 49. What is the average Female students (as % of total students) in Senegal per year?
Make the answer very short. 41.35. What is the average Female students (as % of total students) in West Bank and Gaza per year?
Provide a succinct answer. 50.31. In the year 2000, what is the difference between the Female students (as % of total students) of Kyrgyz Republic and Female students (as % of total students) of Norway?
Give a very brief answer. 0.87. In the year 2000, what is the difference between the Female students (as % of total students) in Kyrgyz Republic and Female students (as % of total students) in Senegal?
Offer a very short reply. 10.99. In the year 2000, what is the difference between the Female students (as % of total students) in Kyrgyz Republic and Female students (as % of total students) in West Bank and Gaza?
Your answer should be compact. 0.12. In the year 2000, what is the difference between the Female students (as % of total students) in Norway and Female students (as % of total students) in Senegal?
Give a very brief answer. 10.13. In the year 2000, what is the difference between the Female students (as % of total students) of Norway and Female students (as % of total students) of West Bank and Gaza?
Your answer should be compact. -0.75. In the year 2000, what is the difference between the Female students (as % of total students) of Senegal and Female students (as % of total students) of West Bank and Gaza?
Your answer should be very brief. -10.87. In the year 2001, what is the difference between the Female students (as % of total students) in Kyrgyz Republic and Female students (as % of total students) in Norway?
Offer a very short reply. 0.21. In the year 2001, what is the difference between the Female students (as % of total students) in Kyrgyz Republic and Female students (as % of total students) in Senegal?
Provide a succinct answer. 9.98. In the year 2001, what is the difference between the Female students (as % of total students) in Kyrgyz Republic and Female students (as % of total students) in West Bank and Gaza?
Your response must be concise. -1.07. In the year 2001, what is the difference between the Female students (as % of total students) of Norway and Female students (as % of total students) of Senegal?
Ensure brevity in your answer.  9.78. In the year 2001, what is the difference between the Female students (as % of total students) of Norway and Female students (as % of total students) of West Bank and Gaza?
Give a very brief answer. -1.28. In the year 2001, what is the difference between the Female students (as % of total students) in Senegal and Female students (as % of total students) in West Bank and Gaza?
Provide a short and direct response. -11.05. In the year 2002, what is the difference between the Female students (as % of total students) in Kyrgyz Republic and Female students (as % of total students) in Norway?
Provide a short and direct response. 0.27. In the year 2002, what is the difference between the Female students (as % of total students) in Kyrgyz Republic and Female students (as % of total students) in Senegal?
Keep it short and to the point. 9.63. In the year 2002, what is the difference between the Female students (as % of total students) in Kyrgyz Republic and Female students (as % of total students) in West Bank and Gaza?
Make the answer very short. -0.73. In the year 2002, what is the difference between the Female students (as % of total students) of Norway and Female students (as % of total students) of Senegal?
Offer a very short reply. 9.36. In the year 2002, what is the difference between the Female students (as % of total students) in Norway and Female students (as % of total students) in West Bank and Gaza?
Make the answer very short. -1. In the year 2002, what is the difference between the Female students (as % of total students) in Senegal and Female students (as % of total students) in West Bank and Gaza?
Your answer should be compact. -10.36. In the year 2004, what is the difference between the Female students (as % of total students) of Kyrgyz Republic and Female students (as % of total students) of Norway?
Your response must be concise. 0.15. In the year 2004, what is the difference between the Female students (as % of total students) of Kyrgyz Republic and Female students (as % of total students) of Senegal?
Keep it short and to the point. 7.99. In the year 2004, what is the difference between the Female students (as % of total students) in Kyrgyz Republic and Female students (as % of total students) in West Bank and Gaza?
Ensure brevity in your answer.  -0.44. In the year 2004, what is the difference between the Female students (as % of total students) in Norway and Female students (as % of total students) in Senegal?
Your answer should be compact. 7.84. In the year 2004, what is the difference between the Female students (as % of total students) in Norway and Female students (as % of total students) in West Bank and Gaza?
Your answer should be very brief. -0.59. In the year 2004, what is the difference between the Female students (as % of total students) in Senegal and Female students (as % of total students) in West Bank and Gaza?
Ensure brevity in your answer.  -8.43. In the year 2005, what is the difference between the Female students (as % of total students) of Kyrgyz Republic and Female students (as % of total students) of Norway?
Ensure brevity in your answer.  0.56. In the year 2005, what is the difference between the Female students (as % of total students) in Kyrgyz Republic and Female students (as % of total students) in Senegal?
Give a very brief answer. 7.04. In the year 2005, what is the difference between the Female students (as % of total students) in Kyrgyz Republic and Female students (as % of total students) in West Bank and Gaza?
Your answer should be compact. -0.61. In the year 2005, what is the difference between the Female students (as % of total students) of Norway and Female students (as % of total students) of Senegal?
Offer a terse response. 6.48. In the year 2005, what is the difference between the Female students (as % of total students) of Norway and Female students (as % of total students) of West Bank and Gaza?
Give a very brief answer. -1.17. In the year 2005, what is the difference between the Female students (as % of total students) of Senegal and Female students (as % of total students) of West Bank and Gaza?
Keep it short and to the point. -7.65. In the year 2006, what is the difference between the Female students (as % of total students) of Kyrgyz Republic and Female students (as % of total students) of Senegal?
Offer a very short reply. 6.71. In the year 2006, what is the difference between the Female students (as % of total students) of Kyrgyz Republic and Female students (as % of total students) of West Bank and Gaza?
Your answer should be very brief. -0.82. In the year 2006, what is the difference between the Female students (as % of total students) of Norway and Female students (as % of total students) of Senegal?
Ensure brevity in your answer.  5.72. In the year 2006, what is the difference between the Female students (as % of total students) of Norway and Female students (as % of total students) of West Bank and Gaza?
Ensure brevity in your answer.  -1.81. In the year 2006, what is the difference between the Female students (as % of total students) in Senegal and Female students (as % of total students) in West Bank and Gaza?
Your answer should be very brief. -7.53. In the year 2008, what is the difference between the Female students (as % of total students) in Kyrgyz Republic and Female students (as % of total students) in Norway?
Provide a short and direct response. 1.27. In the year 2008, what is the difference between the Female students (as % of total students) of Kyrgyz Republic and Female students (as % of total students) of Senegal?
Your response must be concise. 5.49. In the year 2008, what is the difference between the Female students (as % of total students) of Kyrgyz Republic and Female students (as % of total students) of West Bank and Gaza?
Your answer should be compact. -1.3. In the year 2008, what is the difference between the Female students (as % of total students) in Norway and Female students (as % of total students) in Senegal?
Provide a succinct answer. 4.22. In the year 2008, what is the difference between the Female students (as % of total students) in Norway and Female students (as % of total students) in West Bank and Gaza?
Your answer should be compact. -2.57. In the year 2008, what is the difference between the Female students (as % of total students) in Senegal and Female students (as % of total students) in West Bank and Gaza?
Your response must be concise. -6.79. What is the ratio of the Female students (as % of total students) of Kyrgyz Republic in 2000 to that in 2001?
Your answer should be compact. 1.01. What is the ratio of the Female students (as % of total students) in Kyrgyz Republic in 2000 to that in 2002?
Provide a succinct answer. 1.01. What is the ratio of the Female students (as % of total students) of Norway in 2000 to that in 2002?
Ensure brevity in your answer.  1. What is the ratio of the Female students (as % of total students) of Kyrgyz Republic in 2000 to that in 2004?
Offer a terse response. 1.01. What is the ratio of the Female students (as % of total students) of Norway in 2000 to that in 2004?
Ensure brevity in your answer.  1. What is the ratio of the Female students (as % of total students) in Senegal in 2000 to that in 2004?
Provide a succinct answer. 0.94. What is the ratio of the Female students (as % of total students) of West Bank and Gaza in 2000 to that in 2004?
Make the answer very short. 1. What is the ratio of the Female students (as % of total students) in Norway in 2000 to that in 2005?
Offer a terse response. 1.01. What is the ratio of the Female students (as % of total students) of Senegal in 2000 to that in 2005?
Give a very brief answer. 0.92. What is the ratio of the Female students (as % of total students) of West Bank and Gaza in 2000 to that in 2005?
Offer a terse response. 1. What is the ratio of the Female students (as % of total students) of Kyrgyz Republic in 2000 to that in 2006?
Ensure brevity in your answer.  1.01. What is the ratio of the Female students (as % of total students) of Norway in 2000 to that in 2006?
Your response must be concise. 1.02. What is the ratio of the Female students (as % of total students) in Senegal in 2000 to that in 2006?
Provide a short and direct response. 0.92. What is the ratio of the Female students (as % of total students) in Kyrgyz Republic in 2000 to that in 2008?
Give a very brief answer. 1.02. What is the ratio of the Female students (as % of total students) of Norway in 2000 to that in 2008?
Give a very brief answer. 1.03. What is the ratio of the Female students (as % of total students) in Senegal in 2000 to that in 2008?
Your answer should be very brief. 0.89. What is the ratio of the Female students (as % of total students) in West Bank and Gaza in 2000 to that in 2008?
Make the answer very short. 0.99. What is the ratio of the Female students (as % of total students) in Kyrgyz Republic in 2001 to that in 2002?
Keep it short and to the point. 1. What is the ratio of the Female students (as % of total students) of Norway in 2001 to that in 2002?
Your response must be concise. 1. What is the ratio of the Female students (as % of total students) in Senegal in 2001 to that in 2002?
Keep it short and to the point. 0.99. What is the ratio of the Female students (as % of total students) of West Bank and Gaza in 2001 to that in 2002?
Give a very brief answer. 1.01. What is the ratio of the Female students (as % of total students) of Norway in 2001 to that in 2004?
Offer a very short reply. 1. What is the ratio of the Female students (as % of total students) in Senegal in 2001 to that in 2004?
Provide a succinct answer. 0.95. What is the ratio of the Female students (as % of total students) of West Bank and Gaza in 2001 to that in 2004?
Your answer should be very brief. 1.01. What is the ratio of the Female students (as % of total students) of Kyrgyz Republic in 2001 to that in 2005?
Your response must be concise. 1. What is the ratio of the Female students (as % of total students) in Norway in 2001 to that in 2005?
Offer a very short reply. 1.01. What is the ratio of the Female students (as % of total students) in Senegal in 2001 to that in 2005?
Keep it short and to the point. 0.93. What is the ratio of the Female students (as % of total students) in West Bank and Gaza in 2001 to that in 2005?
Offer a terse response. 1.01. What is the ratio of the Female students (as % of total students) of Norway in 2001 to that in 2006?
Offer a terse response. 1.02. What is the ratio of the Female students (as % of total students) of Senegal in 2001 to that in 2006?
Give a very brief answer. 0.92. What is the ratio of the Female students (as % of total students) in Kyrgyz Republic in 2001 to that in 2008?
Your answer should be very brief. 1. What is the ratio of the Female students (as % of total students) of Norway in 2001 to that in 2008?
Provide a succinct answer. 1.02. What is the ratio of the Female students (as % of total students) of Senegal in 2001 to that in 2008?
Your answer should be very brief. 0.9. What is the ratio of the Female students (as % of total students) of West Bank and Gaza in 2001 to that in 2008?
Your answer should be very brief. 1. What is the ratio of the Female students (as % of total students) in Kyrgyz Republic in 2002 to that in 2004?
Make the answer very short. 1. What is the ratio of the Female students (as % of total students) in Senegal in 2002 to that in 2004?
Keep it short and to the point. 0.96. What is the ratio of the Female students (as % of total students) in West Bank and Gaza in 2002 to that in 2004?
Provide a succinct answer. 1. What is the ratio of the Female students (as % of total students) of Norway in 2002 to that in 2005?
Your answer should be very brief. 1.01. What is the ratio of the Female students (as % of total students) in Senegal in 2002 to that in 2005?
Your answer should be very brief. 0.94. What is the ratio of the Female students (as % of total students) in West Bank and Gaza in 2002 to that in 2005?
Keep it short and to the point. 1. What is the ratio of the Female students (as % of total students) of Kyrgyz Republic in 2002 to that in 2006?
Provide a succinct answer. 1. What is the ratio of the Female students (as % of total students) of Norway in 2002 to that in 2006?
Offer a very short reply. 1.02. What is the ratio of the Female students (as % of total students) in Senegal in 2002 to that in 2006?
Your answer should be compact. 0.93. What is the ratio of the Female students (as % of total students) in West Bank and Gaza in 2002 to that in 2006?
Your answer should be compact. 1. What is the ratio of the Female students (as % of total students) of Kyrgyz Republic in 2002 to that in 2008?
Offer a very short reply. 1. What is the ratio of the Female students (as % of total students) in Norway in 2002 to that in 2008?
Make the answer very short. 1.02. What is the ratio of the Female students (as % of total students) of Senegal in 2002 to that in 2008?
Offer a very short reply. 0.91. What is the ratio of the Female students (as % of total students) in Norway in 2004 to that in 2005?
Ensure brevity in your answer.  1.01. What is the ratio of the Female students (as % of total students) of Senegal in 2004 to that in 2005?
Make the answer very short. 0.98. What is the ratio of the Female students (as % of total students) in Norway in 2004 to that in 2006?
Provide a short and direct response. 1.02. What is the ratio of the Female students (as % of total students) of West Bank and Gaza in 2004 to that in 2006?
Provide a short and direct response. 0.99. What is the ratio of the Female students (as % of total students) in Norway in 2004 to that in 2008?
Keep it short and to the point. 1.03. What is the ratio of the Female students (as % of total students) of Senegal in 2004 to that in 2008?
Provide a short and direct response. 0.95. What is the ratio of the Female students (as % of total students) in Kyrgyz Republic in 2005 to that in 2006?
Offer a very short reply. 1. What is the ratio of the Female students (as % of total students) in Norway in 2005 to that in 2006?
Offer a terse response. 1.01. What is the ratio of the Female students (as % of total students) in Senegal in 2005 to that in 2006?
Offer a very short reply. 0.99. What is the ratio of the Female students (as % of total students) in Norway in 2005 to that in 2008?
Your answer should be compact. 1.02. What is the ratio of the Female students (as % of total students) of Senegal in 2005 to that in 2008?
Your answer should be very brief. 0.97. What is the ratio of the Female students (as % of total students) of West Bank and Gaza in 2005 to that in 2008?
Make the answer very short. 0.99. What is the ratio of the Female students (as % of total students) in Kyrgyz Republic in 2006 to that in 2008?
Give a very brief answer. 1. What is the ratio of the Female students (as % of total students) of Norway in 2006 to that in 2008?
Provide a succinct answer. 1.01. What is the ratio of the Female students (as % of total students) of Senegal in 2006 to that in 2008?
Make the answer very short. 0.98. What is the ratio of the Female students (as % of total students) of West Bank and Gaza in 2006 to that in 2008?
Your response must be concise. 0.99. What is the difference between the highest and the second highest Female students (as % of total students) in Kyrgyz Republic?
Your answer should be very brief. 0.63. What is the difference between the highest and the second highest Female students (as % of total students) in Norway?
Offer a terse response. 0.09. What is the difference between the highest and the second highest Female students (as % of total students) of Senegal?
Your response must be concise. 1.06. What is the difference between the highest and the second highest Female students (as % of total students) in West Bank and Gaza?
Offer a very short reply. 0.1. What is the difference between the highest and the lowest Female students (as % of total students) in Kyrgyz Republic?
Give a very brief answer. 0.87. What is the difference between the highest and the lowest Female students (as % of total students) in Norway?
Your answer should be very brief. 1.36. What is the difference between the highest and the lowest Female students (as % of total students) of Senegal?
Your response must be concise. 4.64. What is the difference between the highest and the lowest Female students (as % of total students) in West Bank and Gaza?
Provide a succinct answer. 0.62. 